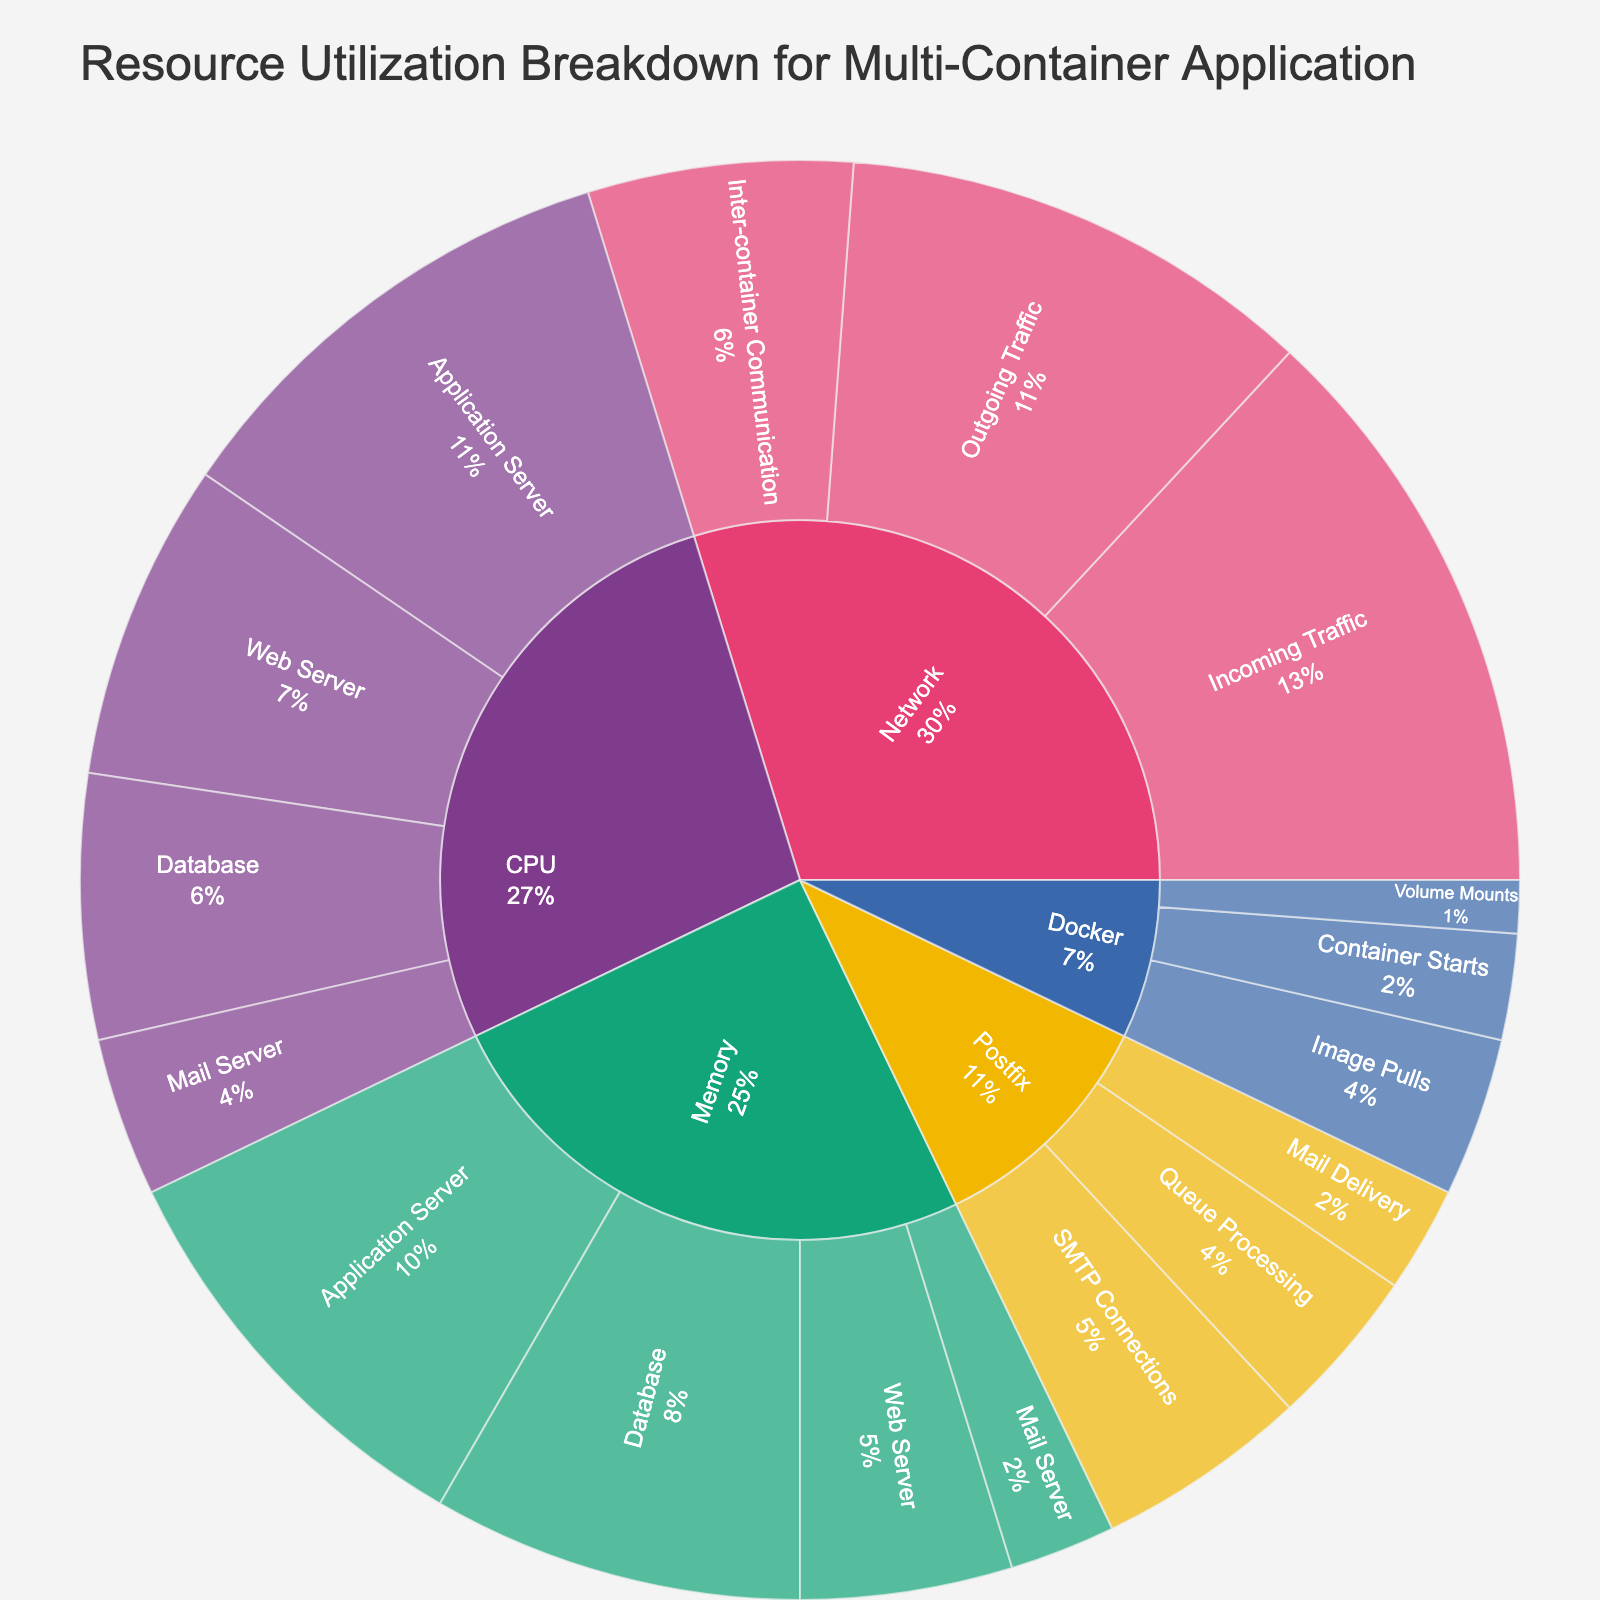What is the title of the sunburst plot? The title of the sunburst plot is typically displayed at the top of the figure in a larger font. In this case, it reads "Resource Utilization Breakdown for Multi-Container Application."
Answer: Resource Utilization Breakdown for Multi-Container Application Which subcategory under the 'CPU' category has the highest value? To determine this, examine the 'CPU' category and check the values associated with its subcategories. The 'Application Server' has the highest value at 45.
Answer: Application Server What percentage of the total value is attributed to the 'Memory' category? The total value includes all categories. First, sum up the values for all subcategories: 30+45+25+15+20+40+35+10+55+45+25+15+10+5+20+15+10 = 400. Then sum the 'Memory' subcategories: 20 + 40 + 35 + 10 = 105. Finally, compute the percentage: (105/400) * 100 = 26.25%.
Answer: 26.25% How does the value of 'Network' compare to the 'Docker' category? Sum the values under 'Network': 55+45+25=125. Sum the values under 'Docker': 15+10+5=30. 'Network' has a higher total value (125) compared to 'Docker' (30).
Answer: Network 125 > Docker 30 Which category has the least total value and what is that value? Sum values for each category (CPU: 115, Memory: 105, Network: 125, Docker: 30, Postfix: 45). The 'Docker' category has the least total value, which is 30.
Answer: Docker 30 What is the combined value of 'Web Server' across 'CPU' and 'Memory'? Check the values for 'Web Server' under both categories: CPU is 30, and Memory is 20. Add them: 30 + 20 = 50.
Answer: 50 How much higher is the 'Outgoing Traffic' compared to 'Inter-container Communication' in the 'Network' category? Subtract the value of 'Inter-container Communication' (25) from 'Outgoing Traffic' (45): 45 - 25 = 20.
Answer: 20 What percentage of 'CPU' is utilized by the 'Database'? The total 'CPU' value is 115. The 'Database' consumes 25. Compute the percentage: (25/115) * 100 ≈ 21.74%.
Answer: 21.74% How does the value of 'Mail Delivery' in the 'Postfix' category compare to 'Volume Mounts' in the 'Docker' category? 'Mail Delivery' has a value of 10 and 'Volume Mounts' has a value of 5. 'Mail Delivery' is higher.
Answer: Mail Delivery 10 > Volume Mounts 5 